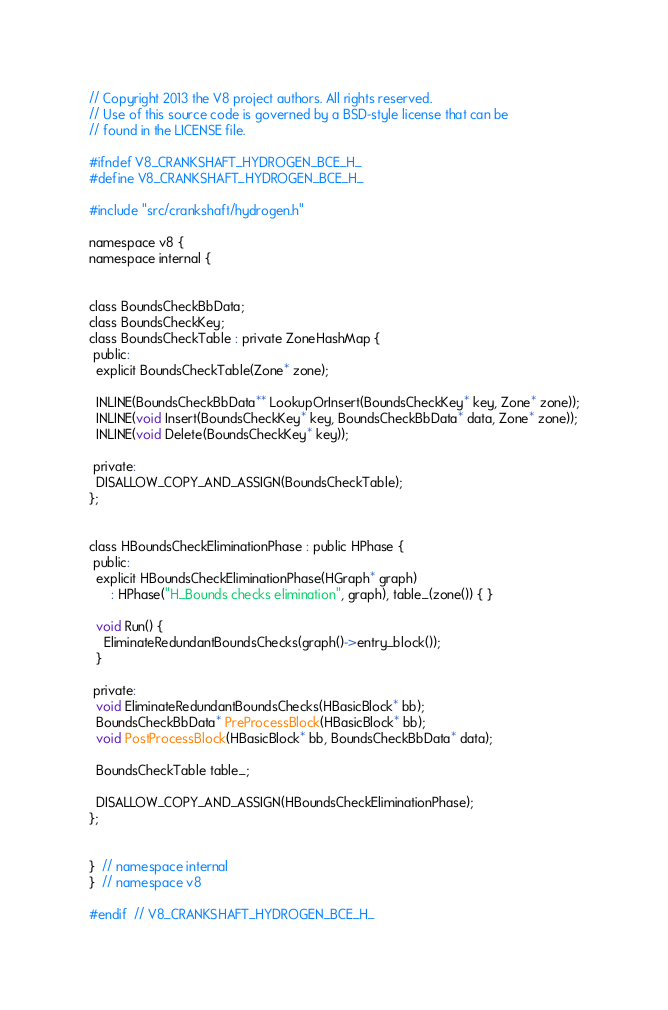<code> <loc_0><loc_0><loc_500><loc_500><_C_>// Copyright 2013 the V8 project authors. All rights reserved.
// Use of this source code is governed by a BSD-style license that can be
// found in the LICENSE file.

#ifndef V8_CRANKSHAFT_HYDROGEN_BCE_H_
#define V8_CRANKSHAFT_HYDROGEN_BCE_H_

#include "src/crankshaft/hydrogen.h"

namespace v8 {
namespace internal {


class BoundsCheckBbData;
class BoundsCheckKey;
class BoundsCheckTable : private ZoneHashMap {
 public:
  explicit BoundsCheckTable(Zone* zone);

  INLINE(BoundsCheckBbData** LookupOrInsert(BoundsCheckKey* key, Zone* zone));
  INLINE(void Insert(BoundsCheckKey* key, BoundsCheckBbData* data, Zone* zone));
  INLINE(void Delete(BoundsCheckKey* key));

 private:
  DISALLOW_COPY_AND_ASSIGN(BoundsCheckTable);
};


class HBoundsCheckEliminationPhase : public HPhase {
 public:
  explicit HBoundsCheckEliminationPhase(HGraph* graph)
      : HPhase("H_Bounds checks elimination", graph), table_(zone()) { }

  void Run() {
    EliminateRedundantBoundsChecks(graph()->entry_block());
  }

 private:
  void EliminateRedundantBoundsChecks(HBasicBlock* bb);
  BoundsCheckBbData* PreProcessBlock(HBasicBlock* bb);
  void PostProcessBlock(HBasicBlock* bb, BoundsCheckBbData* data);

  BoundsCheckTable table_;

  DISALLOW_COPY_AND_ASSIGN(HBoundsCheckEliminationPhase);
};


}  // namespace internal
}  // namespace v8

#endif  // V8_CRANKSHAFT_HYDROGEN_BCE_H_
</code> 